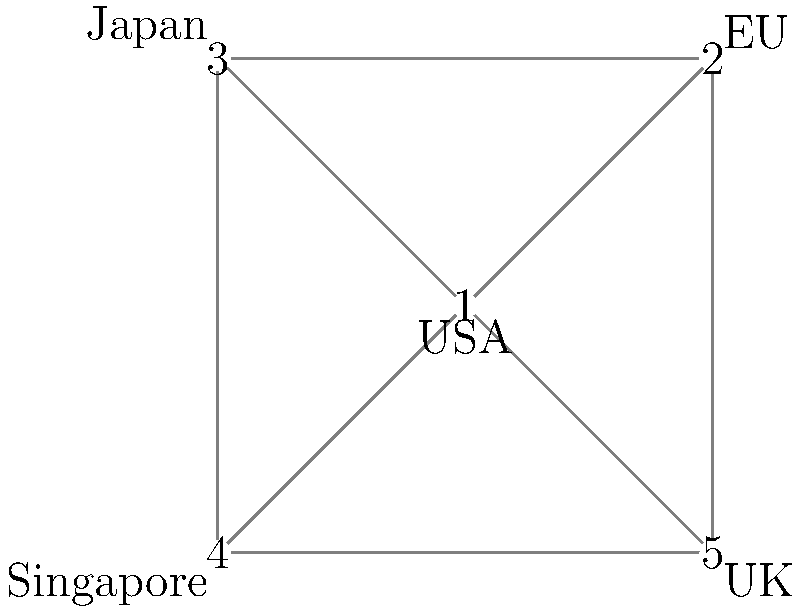In the node-link diagram representing international cooperation in cryptocurrency regulation, which country (node) has the highest degree centrality, and what does this imply about its role in global crypto regulation? To answer this question, we need to follow these steps:

1. Understand degree centrality:
   Degree centrality is a measure of the number of direct connections a node has in a network.

2. Count the connections for each node:
   Node 1 (USA): 4 connections
   Node 2 (EU): 3 connections
   Node 3 (Japan): 3 connections
   Node 4 (Singapore): 3 connections
   Node 5 (UK): 3 connections

3. Identify the node with the highest degree centrality:
   Node 1 (USA) has the highest degree centrality with 4 connections.

4. Interpret the implications:
   The country with the highest degree centrality (USA) is likely to have the most influence in global cryptocurrency regulation. This implies that:
   
   a) The USA is a central player in international crypto regulatory cooperation.
   b) It has direct communication channels with more countries than any other in the network.
   c) The USA may have a greater ability to influence or coordinate global regulatory efforts.
   d) Other countries may look to the USA for leadership or guidance in crypto regulation.
   e) The USA might be more involved in information sharing and policy harmonization efforts.

5. Consider the limitations:
   While degree centrality is informative, it doesn't account for the quality or strength of connections, nor does it consider indirect influences in the network.
Answer: USA; central role in global crypto regulatory cooperation 